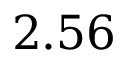Convert formula to latex. <formula><loc_0><loc_0><loc_500><loc_500>2 . 5 6</formula> 